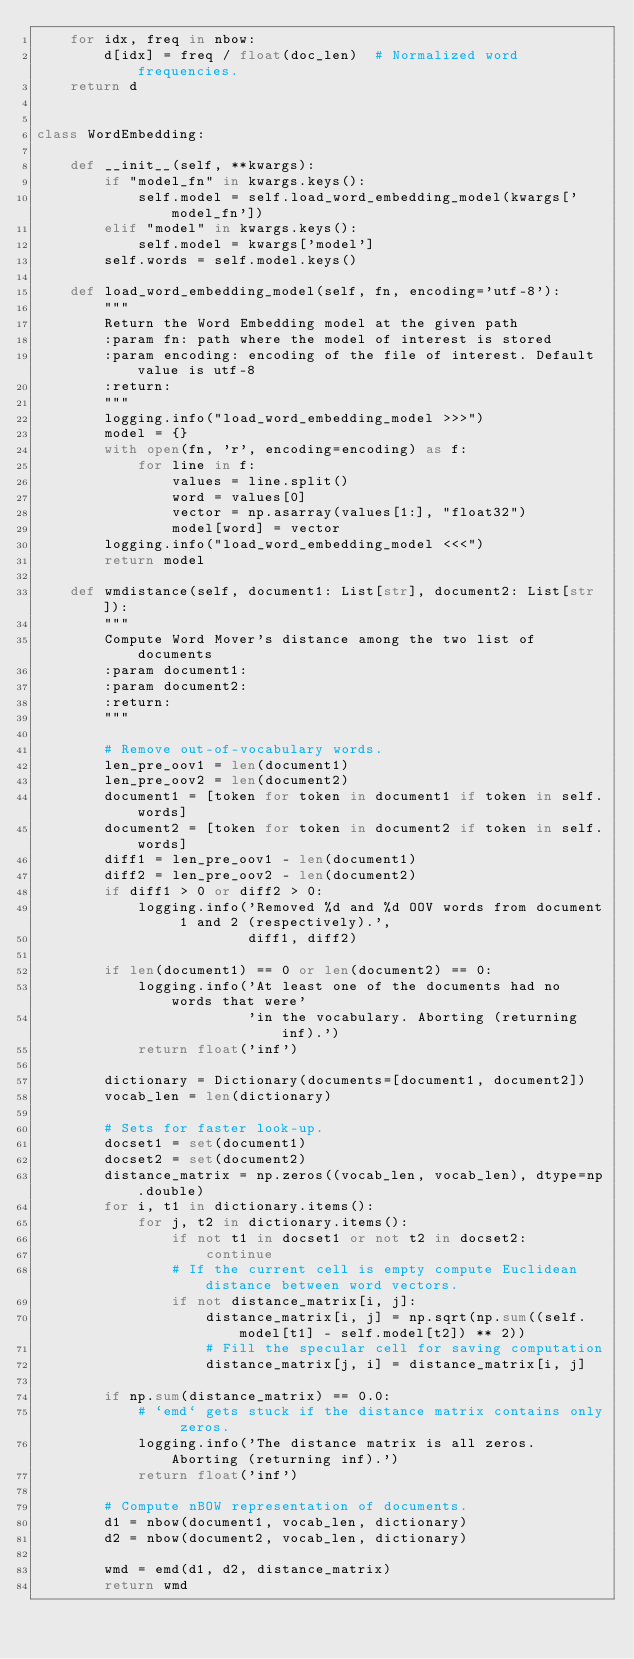<code> <loc_0><loc_0><loc_500><loc_500><_Python_>    for idx, freq in nbow:
        d[idx] = freq / float(doc_len)  # Normalized word frequencies.
    return d


class WordEmbedding:

    def __init__(self, **kwargs):
        if "model_fn" in kwargs.keys():
            self.model = self.load_word_embedding_model(kwargs['model_fn'])
        elif "model" in kwargs.keys():
            self.model = kwargs['model']
        self.words = self.model.keys()

    def load_word_embedding_model(self, fn, encoding='utf-8'):
        """
        Return the Word Embedding model at the given path
        :param fn: path where the model of interest is stored
        :param encoding: encoding of the file of interest. Default value is utf-8
        :return:
        """
        logging.info("load_word_embedding_model >>>")
        model = {}
        with open(fn, 'r', encoding=encoding) as f:
            for line in f:
                values = line.split()
                word = values[0]
                vector = np.asarray(values[1:], "float32")
                model[word] = vector
        logging.info("load_word_embedding_model <<<")
        return model

    def wmdistance(self, document1: List[str], document2: List[str]):
        """
        Compute Word Mover's distance among the two list of documents
        :param document1:
        :param document2:
        :return:
        """

        # Remove out-of-vocabulary words.
        len_pre_oov1 = len(document1)
        len_pre_oov2 = len(document2)
        document1 = [token for token in document1 if token in self.words]
        document2 = [token for token in document2 if token in self.words]
        diff1 = len_pre_oov1 - len(document1)
        diff2 = len_pre_oov2 - len(document2)
        if diff1 > 0 or diff2 > 0:
            logging.info('Removed %d and %d OOV words from document 1 and 2 (respectively).',
                         diff1, diff2)

        if len(document1) == 0 or len(document2) == 0:
            logging.info('At least one of the documents had no words that were'
                         'in the vocabulary. Aborting (returning inf).')
            return float('inf')

        dictionary = Dictionary(documents=[document1, document2])
        vocab_len = len(dictionary)

        # Sets for faster look-up.
        docset1 = set(document1)
        docset2 = set(document2)
        distance_matrix = np.zeros((vocab_len, vocab_len), dtype=np.double)
        for i, t1 in dictionary.items():
            for j, t2 in dictionary.items():
                if not t1 in docset1 or not t2 in docset2:
                    continue
                # If the current cell is empty compute Euclidean distance between word vectors.
                if not distance_matrix[i, j]:
                    distance_matrix[i, j] = np.sqrt(np.sum((self.model[t1] - self.model[t2]) ** 2))
                    # Fill the specular cell for saving computation
                    distance_matrix[j, i] = distance_matrix[i, j]

        if np.sum(distance_matrix) == 0.0:
            # `emd` gets stuck if the distance matrix contains only zeros.
            logging.info('The distance matrix is all zeros. Aborting (returning inf).')
            return float('inf')

        # Compute nBOW representation of documents.
        d1 = nbow(document1, vocab_len, dictionary)
        d2 = nbow(document2, vocab_len, dictionary)

        wmd = emd(d1, d2, distance_matrix)
        return wmd
</code> 